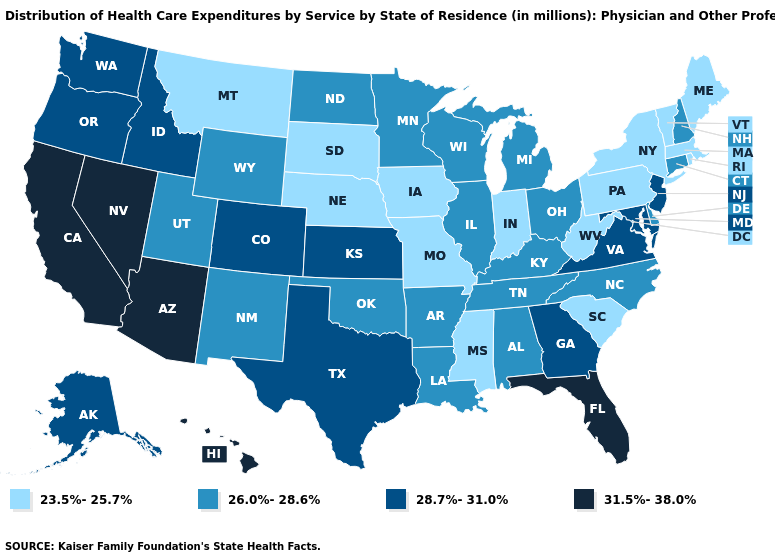Name the states that have a value in the range 31.5%-38.0%?
Write a very short answer. Arizona, California, Florida, Hawaii, Nevada. How many symbols are there in the legend?
Write a very short answer. 4. What is the value of Florida?
Keep it brief. 31.5%-38.0%. What is the value of Nebraska?
Keep it brief. 23.5%-25.7%. What is the value of Iowa?
Be succinct. 23.5%-25.7%. Name the states that have a value in the range 28.7%-31.0%?
Give a very brief answer. Alaska, Colorado, Georgia, Idaho, Kansas, Maryland, New Jersey, Oregon, Texas, Virginia, Washington. Does Minnesota have the highest value in the USA?
Give a very brief answer. No. What is the value of Georgia?
Be succinct. 28.7%-31.0%. What is the value of Hawaii?
Write a very short answer. 31.5%-38.0%. What is the highest value in the South ?
Keep it brief. 31.5%-38.0%. What is the value of Oregon?
Give a very brief answer. 28.7%-31.0%. Is the legend a continuous bar?
Be succinct. No. Name the states that have a value in the range 31.5%-38.0%?
Give a very brief answer. Arizona, California, Florida, Hawaii, Nevada. Name the states that have a value in the range 23.5%-25.7%?
Short answer required. Indiana, Iowa, Maine, Massachusetts, Mississippi, Missouri, Montana, Nebraska, New York, Pennsylvania, Rhode Island, South Carolina, South Dakota, Vermont, West Virginia. Among the states that border Washington , which have the lowest value?
Be succinct. Idaho, Oregon. 